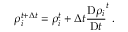Convert formula to latex. <formula><loc_0><loc_0><loc_500><loc_500>\rho _ { i } ^ { t + \Delta t } = \rho _ { i } ^ { t } + \Delta t \frac { D \rho _ { i } } { D t } ^ { t } \, .</formula> 